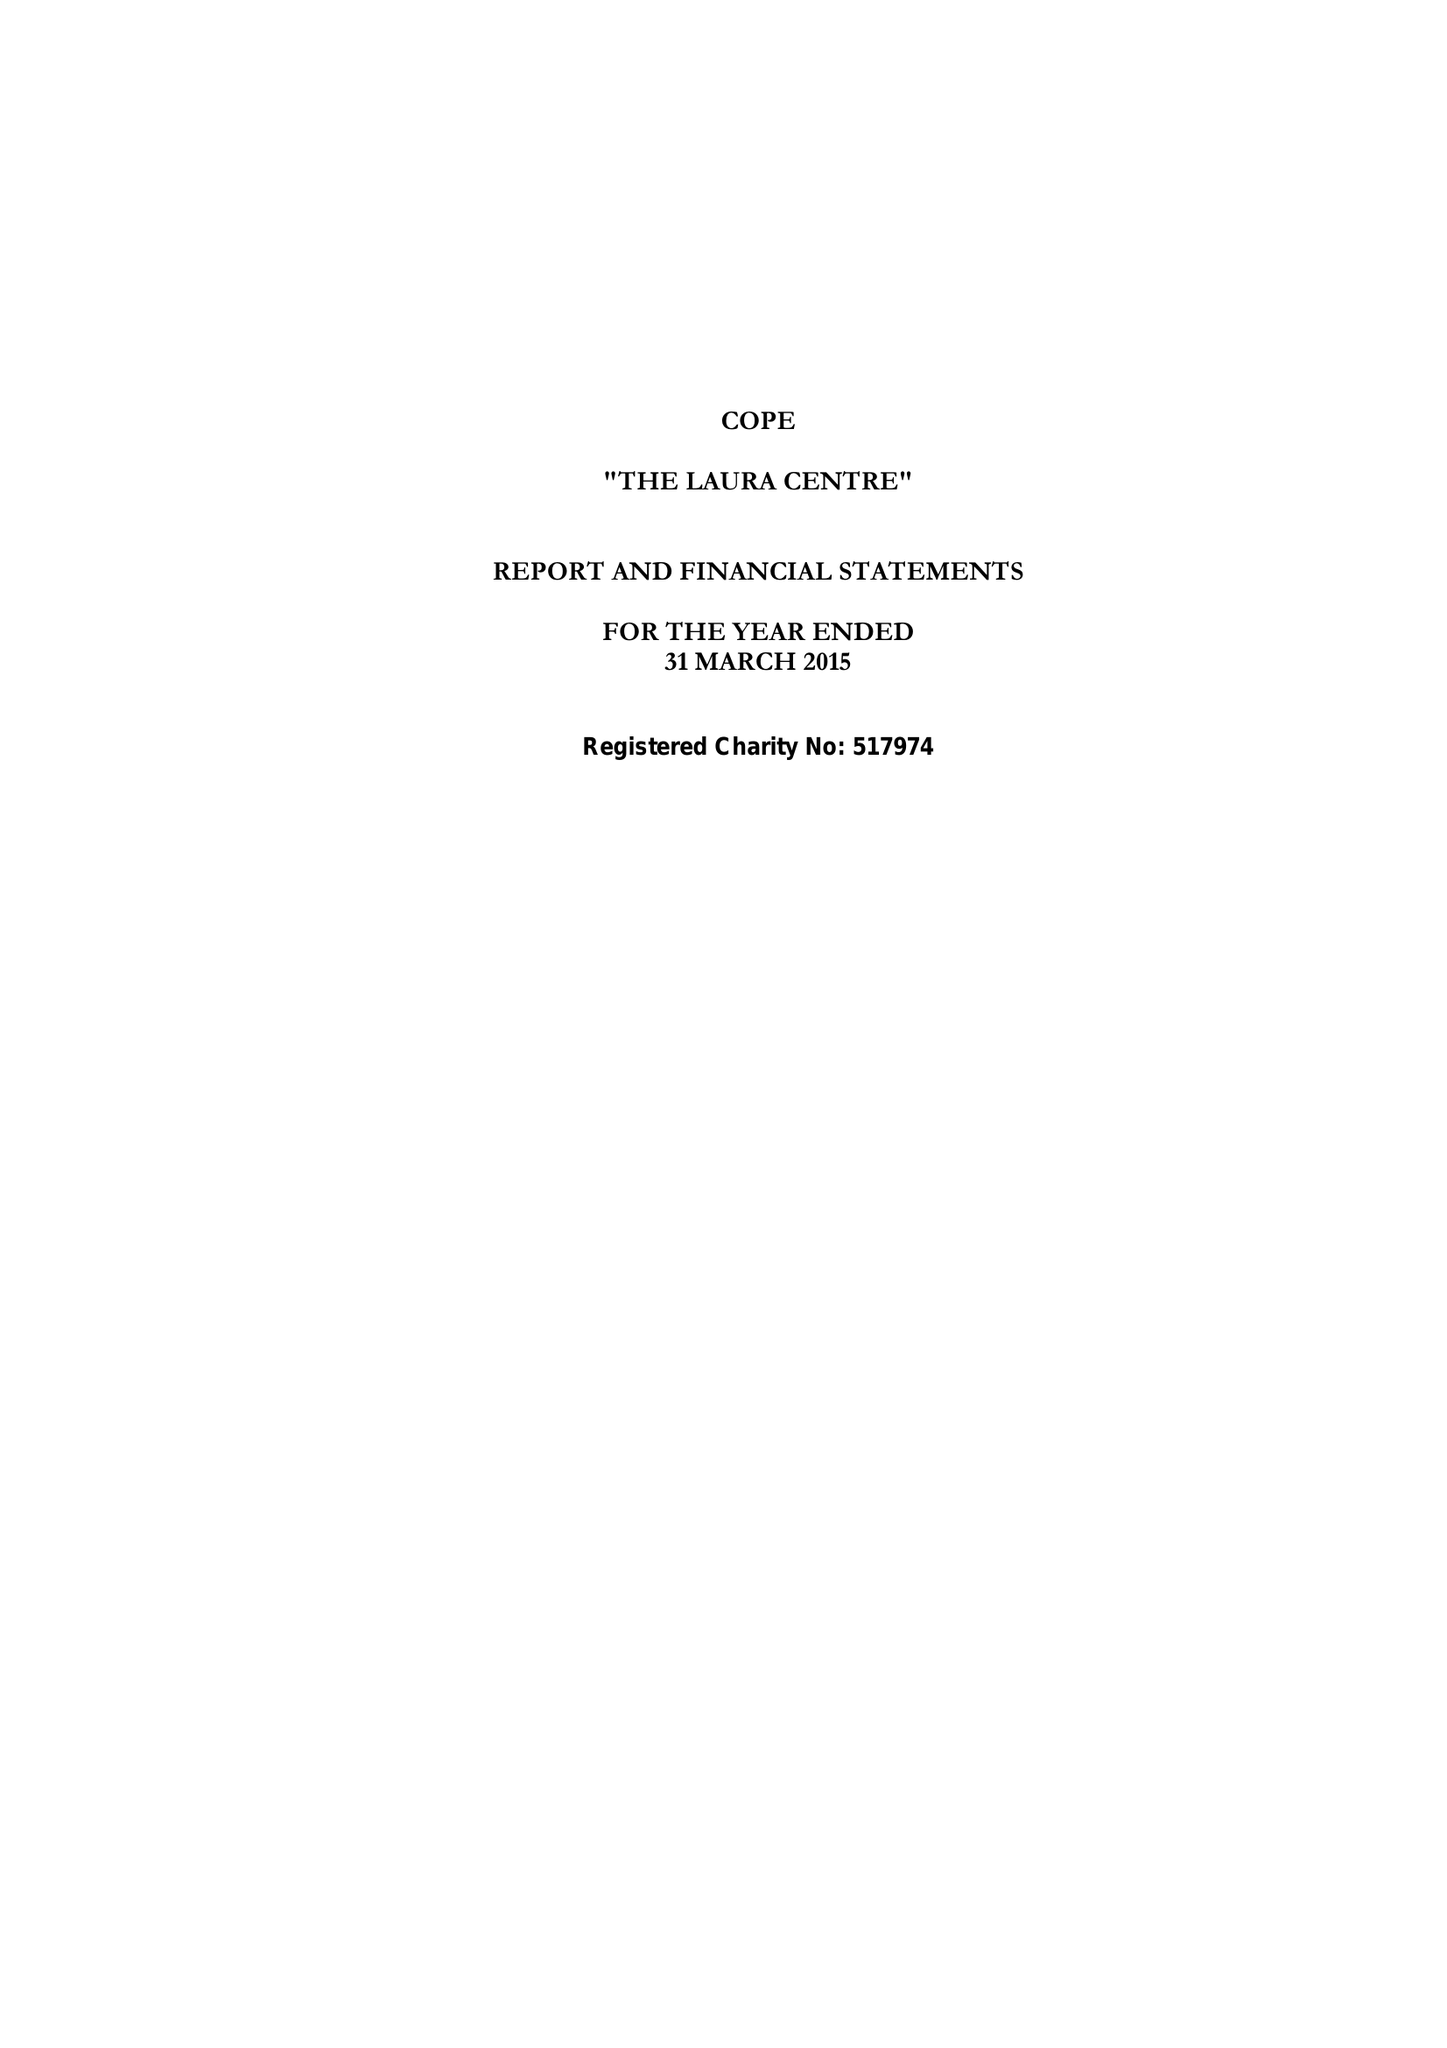What is the value for the charity_number?
Answer the question using a single word or phrase. 517974 